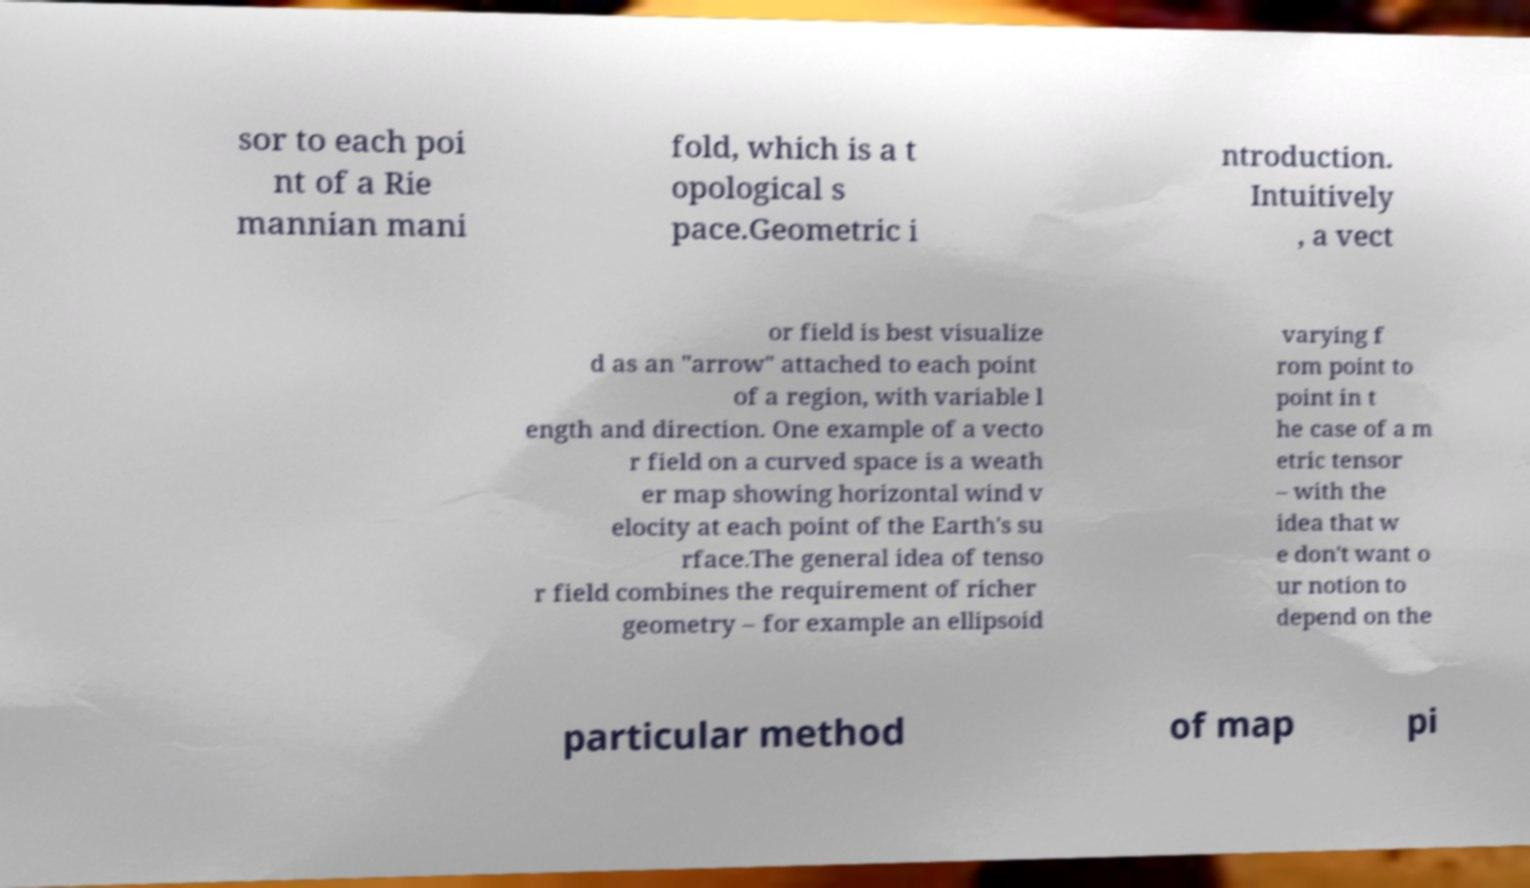For documentation purposes, I need the text within this image transcribed. Could you provide that? sor to each poi nt of a Rie mannian mani fold, which is a t opological s pace.Geometric i ntroduction. Intuitively , a vect or field is best visualize d as an "arrow" attached to each point of a region, with variable l ength and direction. One example of a vecto r field on a curved space is a weath er map showing horizontal wind v elocity at each point of the Earth's su rface.The general idea of tenso r field combines the requirement of richer geometry – for example an ellipsoid varying f rom point to point in t he case of a m etric tensor – with the idea that w e don't want o ur notion to depend on the particular method of map pi 